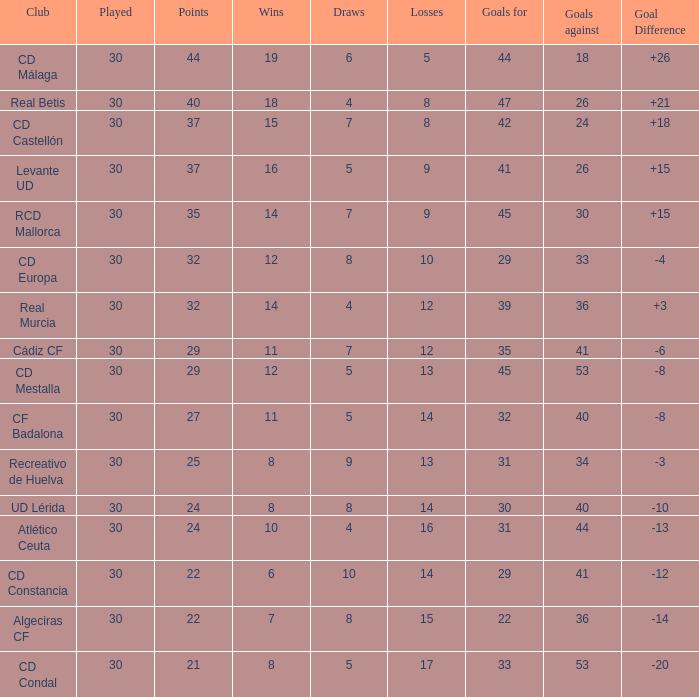What is the number of wins when the goals against is larger than 41, points is 29, and draws are larger than 5? 0.0. 